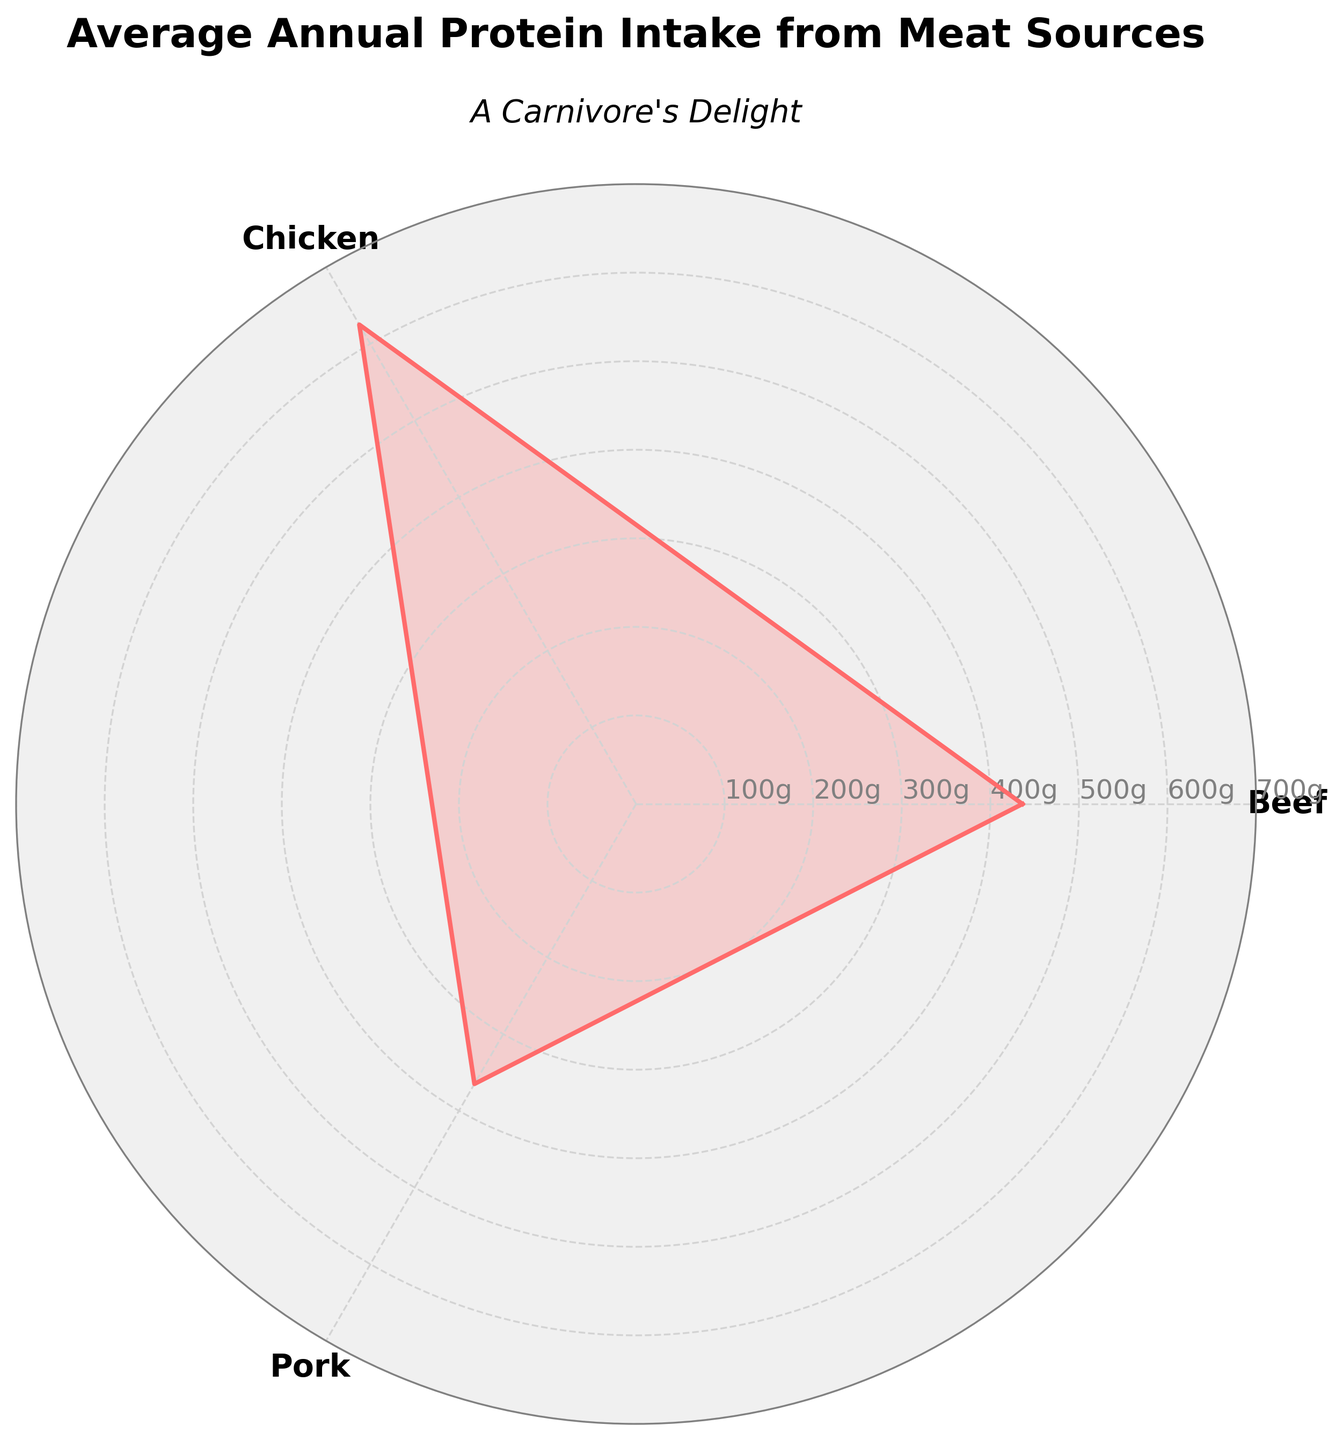What is the title of the plot? The title of the plot is displayed at the top, and it specifies what the plot represents.
Answer: Average Annual Protein Intake from Meat Sources What are the categories shown in the plot? The categories are the meat sources labeled on the radial axes.
Answer: Beef, Chicken, Pork Which meat source has the highest average annual protein intake? By comparing the radial distances for each meat source, Chicken has the highest average intake.
Answer: Chicken How much is the average annual protein intake for Pork? The radial line for Pork shows its average intake.
Answer: 365g What is the difference between the average annual protein intakes of Beef and Chicken? The average intake of Beef is 436.25g and for Chicken it is 625g. Subtracting these values gives 625 - 436.25 = 188.75g.
Answer: 188.75g Which meat source has the lowest average annual protein intake, and what is the value? By observing the radial distances, Beef has the lowest average intake and its value is marked.
Answer: Beef, 436.25g How do the average annual protein intakes of Chicken and Pork compare? The radial line for Chicken shows a higher value than that for Pork.
Answer: Chicken has a higher intake than Pork What is the average intake across all three meat sources? The values are 436.25 (Beef), 625 (Chicken), 365 (Pork). The average is (436.25 + 625 + 365) / 3 ≈ 475.42g.
Answer: 475.42g 